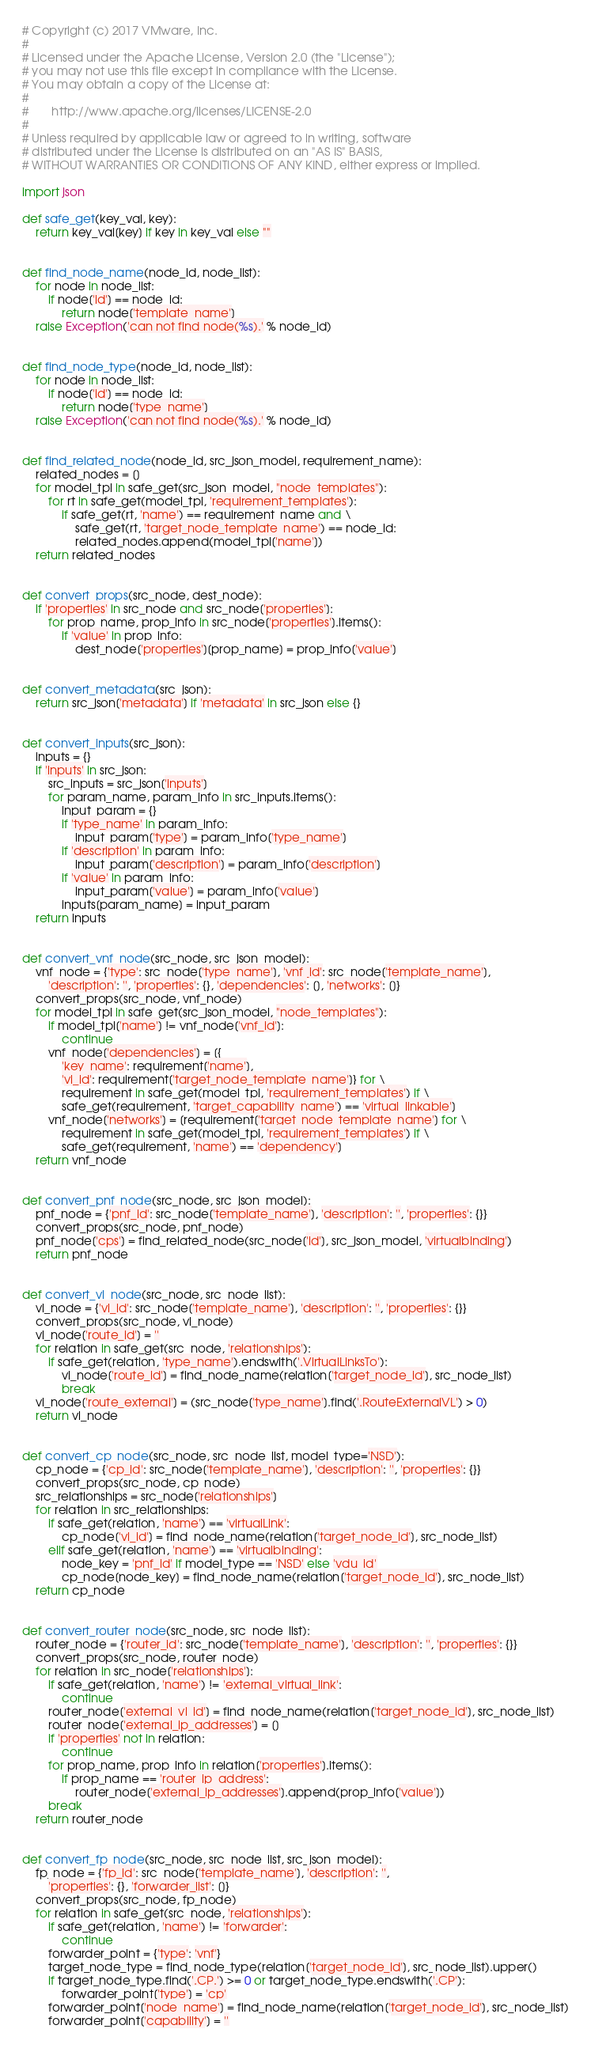Convert code to text. <code><loc_0><loc_0><loc_500><loc_500><_Python_># Copyright (c) 2017 VMware, Inc.
#
# Licensed under the Apache License, Version 2.0 (the "License");
# you may not use this file except in compliance with the License.
# You may obtain a copy of the License at:
#
#       http://www.apache.org/licenses/LICENSE-2.0
#
# Unless required by applicable law or agreed to in writing, software
# distributed under the License is distributed on an "AS IS" BASIS,
# WITHOUT WARRANTIES OR CONDITIONS OF ANY KIND, either express or implied.

import json

def safe_get(key_val, key):
    return key_val[key] if key in key_val else ""


def find_node_name(node_id, node_list):
    for node in node_list:
        if node['id'] == node_id:
            return node['template_name']
    raise Exception('can not find node(%s).' % node_id)


def find_node_type(node_id, node_list):
    for node in node_list:
        if node['id'] == node_id:
            return node['type_name']
    raise Exception('can not find node(%s).' % node_id)


def find_related_node(node_id, src_json_model, requirement_name):
    related_nodes = []
    for model_tpl in safe_get(src_json_model, "node_templates"):
        for rt in safe_get(model_tpl, 'requirement_templates'):
            if safe_get(rt, 'name') == requirement_name and \
                safe_get(rt, 'target_node_template_name') == node_id:
                related_nodes.append(model_tpl['name'])
    return related_nodes


def convert_props(src_node, dest_node):
    if 'properties' in src_node and src_node['properties']:
        for prop_name, prop_info in src_node['properties'].items():
            if 'value' in prop_info:
                dest_node['properties'][prop_name] = prop_info['value']   


def convert_metadata(src_json):
    return src_json['metadata'] if 'metadata' in src_json else {}


def convert_inputs(src_json):
    inputs = {}
    if 'inputs' in src_json:
        src_inputs = src_json['inputs']
        for param_name, param_info in src_inputs.items():
            input_param = {}
            if 'type_name' in param_info:
                input_param['type'] = param_info['type_name']
            if 'description' in param_info:
                input_param['description'] = param_info['description']
            if 'value' in param_info:
                input_param['value'] = param_info['value']
            inputs[param_name] = input_param
    return inputs


def convert_vnf_node(src_node, src_json_model):
    vnf_node = {'type': src_node['type_name'], 'vnf_id': src_node['template_name'],
        'description': '', 'properties': {}, 'dependencies': [], 'networks': []}
    convert_props(src_node, vnf_node)
    for model_tpl in safe_get(src_json_model, "node_templates"):
        if model_tpl['name'] != vnf_node['vnf_id']:
            continue
        vnf_node['dependencies'] = [{
            'key_name': requirement['name'],
            'vl_id': requirement['target_node_template_name']} for \
            requirement in safe_get(model_tpl, 'requirement_templates') if \
            safe_get(requirement, 'target_capability_name') == 'virtual_linkable']
        vnf_node['networks'] = [requirement['target_node_template_name'] for \
            requirement in safe_get(model_tpl, 'requirement_templates') if \
            safe_get(requirement, 'name') == 'dependency']
    return vnf_node


def convert_pnf_node(src_node, src_json_model):
    pnf_node = {'pnf_id': src_node['template_name'], 'description': '', 'properties': {}}
    convert_props(src_node, pnf_node)
    pnf_node['cps'] = find_related_node(src_node['id'], src_json_model, 'virtualbinding')
    return pnf_node


def convert_vl_node(src_node, src_node_list):
    vl_node = {'vl_id': src_node['template_name'], 'description': '', 'properties': {}}
    convert_props(src_node, vl_node)
    vl_node['route_id'] = ''
    for relation in safe_get(src_node, 'relationships'):
        if safe_get(relation, 'type_name').endswith('.VirtualLinksTo'):
            vl_node['route_id'] = find_node_name(relation['target_node_id'], src_node_list)
            break
    vl_node['route_external'] = (src_node['type_name'].find('.RouteExternalVL') > 0)
    return vl_node


def convert_cp_node(src_node, src_node_list, model_type='NSD'):
    cp_node = {'cp_id': src_node['template_name'], 'description': '', 'properties': {}}
    convert_props(src_node, cp_node)
    src_relationships = src_node['relationships']
    for relation in src_relationships:
        if safe_get(relation, 'name') == 'virtualLink':
            cp_node['vl_id'] = find_node_name(relation['target_node_id'], src_node_list)
        elif safe_get(relation, 'name') == 'virtualbinding':
            node_key = 'pnf_id' if model_type == 'NSD' else 'vdu_id'
            cp_node[node_key] = find_node_name(relation['target_node_id'], src_node_list)
    return cp_node


def convert_router_node(src_node, src_node_list):
    router_node = {'router_id': src_node['template_name'], 'description': '', 'properties': {}}
    convert_props(src_node, router_node)
    for relation in src_node['relationships']:
        if safe_get(relation, 'name') != 'external_virtual_link':
            continue
        router_node['external_vl_id'] = find_node_name(relation['target_node_id'], src_node_list)
        router_node['external_ip_addresses'] = []
        if 'properties' not in relation:
            continue
        for prop_name, prop_info in relation['properties'].items():
            if prop_name == 'router_ip_address':
                router_node['external_ip_addresses'].append(prop_info['value'])
        break
    return router_node


def convert_fp_node(src_node, src_node_list, src_json_model):
    fp_node = {'fp_id': src_node['template_name'], 'description': '', 
        'properties': {}, 'forwarder_list': []}
    convert_props(src_node, fp_node)
    for relation in safe_get(src_node, 'relationships'):
        if safe_get(relation, 'name') != 'forwarder':
            continue
        forwarder_point = {'type': 'vnf'}
        target_node_type = find_node_type(relation['target_node_id'], src_node_list).upper()
        if target_node_type.find('.CP.') >= 0 or target_node_type.endswith('.CP'):
            forwarder_point['type'] = 'cp'
        forwarder_point['node_name'] = find_node_name(relation['target_node_id'], src_node_list)
        forwarder_point['capability'] = ''</code> 